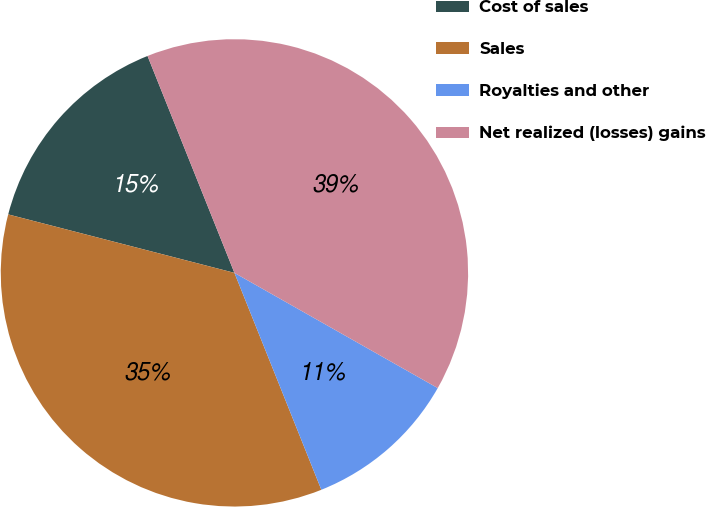Convert chart. <chart><loc_0><loc_0><loc_500><loc_500><pie_chart><fcel>Cost of sales<fcel>Sales<fcel>Royalties and other<fcel>Net realized (losses) gains<nl><fcel>14.91%<fcel>35.09%<fcel>10.73%<fcel>39.27%<nl></chart> 